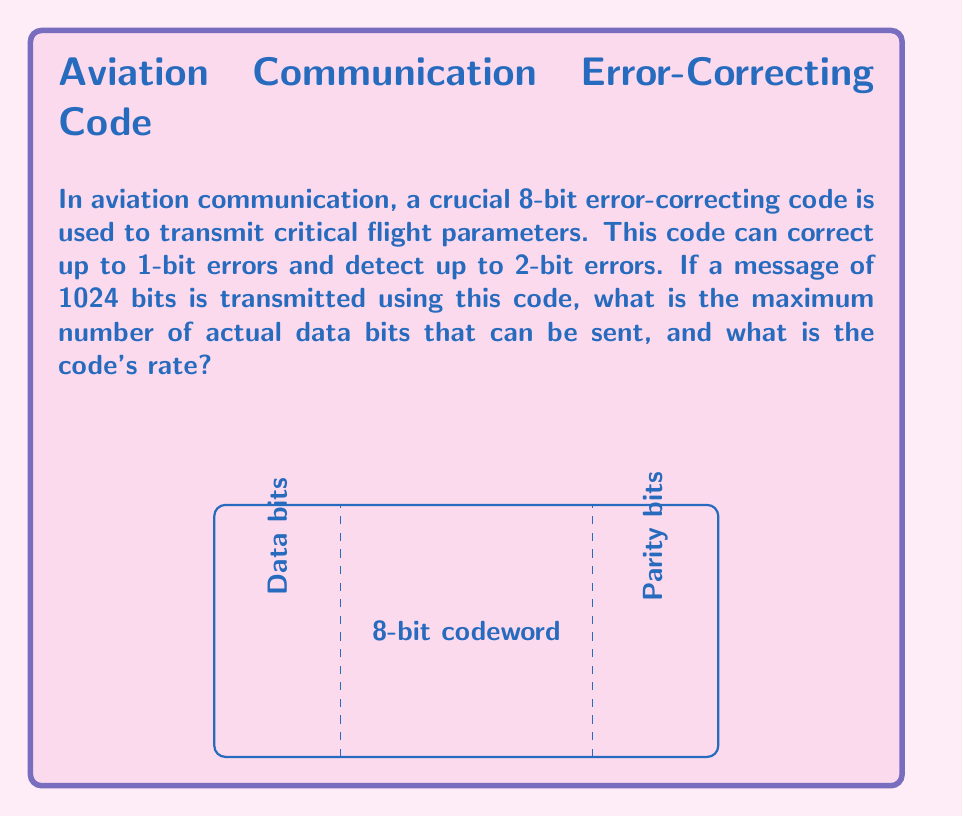Provide a solution to this math problem. Let's approach this step-by-step:

1) First, we need to understand the structure of the code. An 8-bit code that can correct 1-bit errors and detect 2-bit errors is likely using 4 parity bits.

2) In a typical error-correcting code, the number of parity bits (r) must satisfy:

   $$2^r \geq n + r + 1$$

   where n is the number of data bits.

3) In our case, with 8-bit codewords and 4 parity bits:

   $$2^4 \geq 4 + 4 + 1$$
   $$16 \geq 9$$

   This satisfies the condition.

4) So, each 8-bit codeword contains 4 data bits and 4 parity bits.

5) Now, for a 1024-bit message, we need to calculate how many 8-bit codewords it contains:

   $$1024 \div 8 = 128$$ codewords

6) Each codeword carries 4 data bits, so the total number of data bits is:

   $$128 \times 4 = 512$$ data bits

7) The code rate is defined as the ratio of data bits to total bits:

   $$\text{Rate} = \frac{\text{Data bits}}{\text{Total bits}} = \frac{512}{1024} = \frac{1}{2} = 0.5$$
Answer: 512 data bits; Code rate: 0.5 